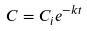Convert formula to latex. <formula><loc_0><loc_0><loc_500><loc_500>C = C _ { i } e ^ { - k t }</formula> 